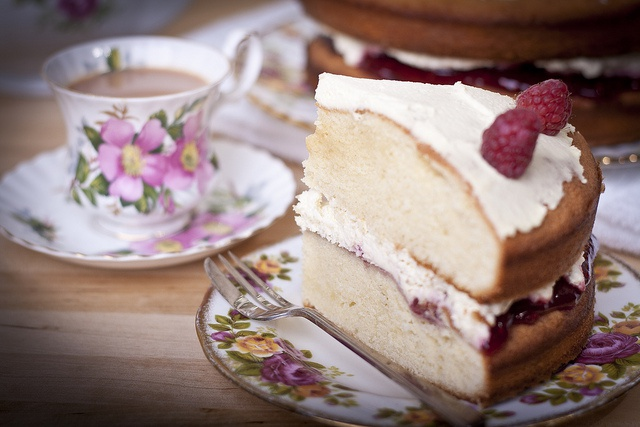Describe the objects in this image and their specific colors. I can see dining table in lightgray, darkgray, maroon, and black tones, cake in black, lightgray, maroon, and tan tones, cup in black, lavender, darkgray, and pink tones, and fork in black, gray, and darkgray tones in this image. 